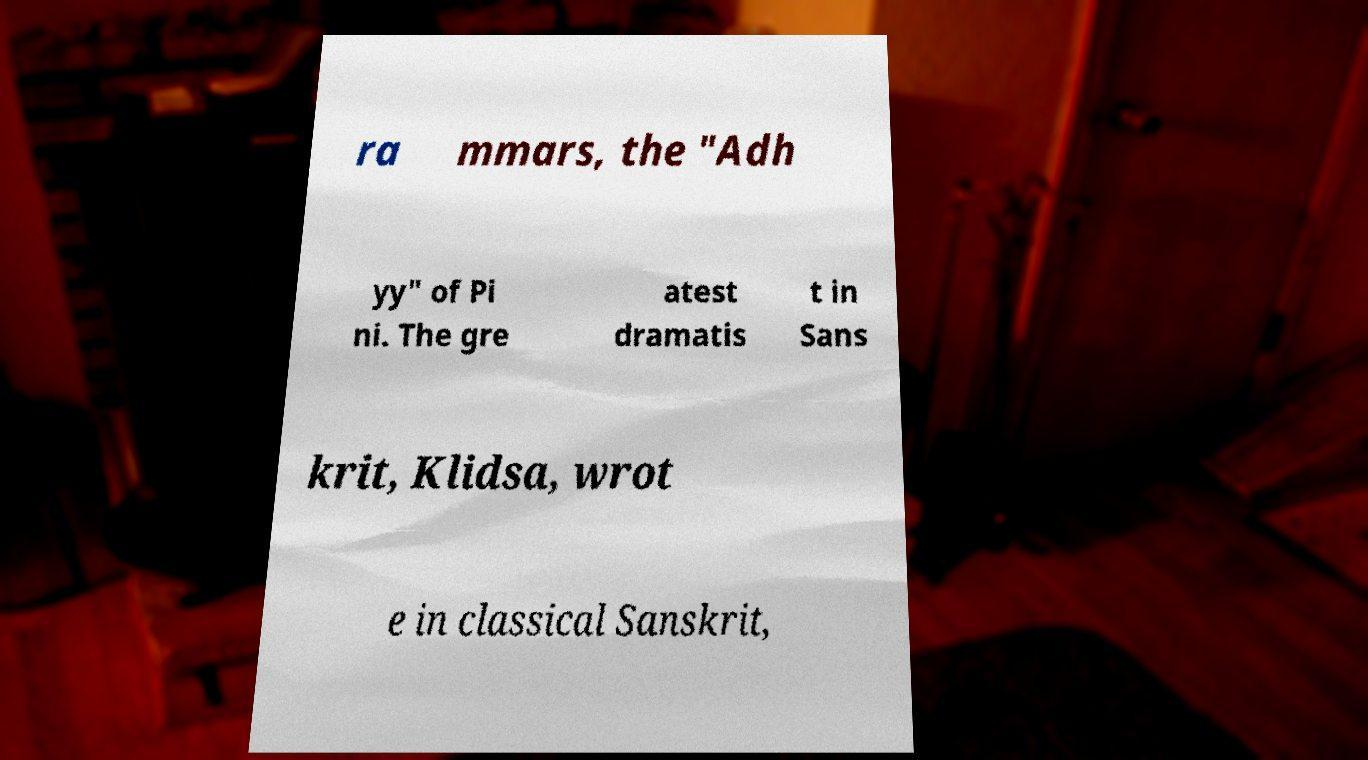There's text embedded in this image that I need extracted. Can you transcribe it verbatim? ra mmars, the "Adh yy" of Pi ni. The gre atest dramatis t in Sans krit, Klidsa, wrot e in classical Sanskrit, 